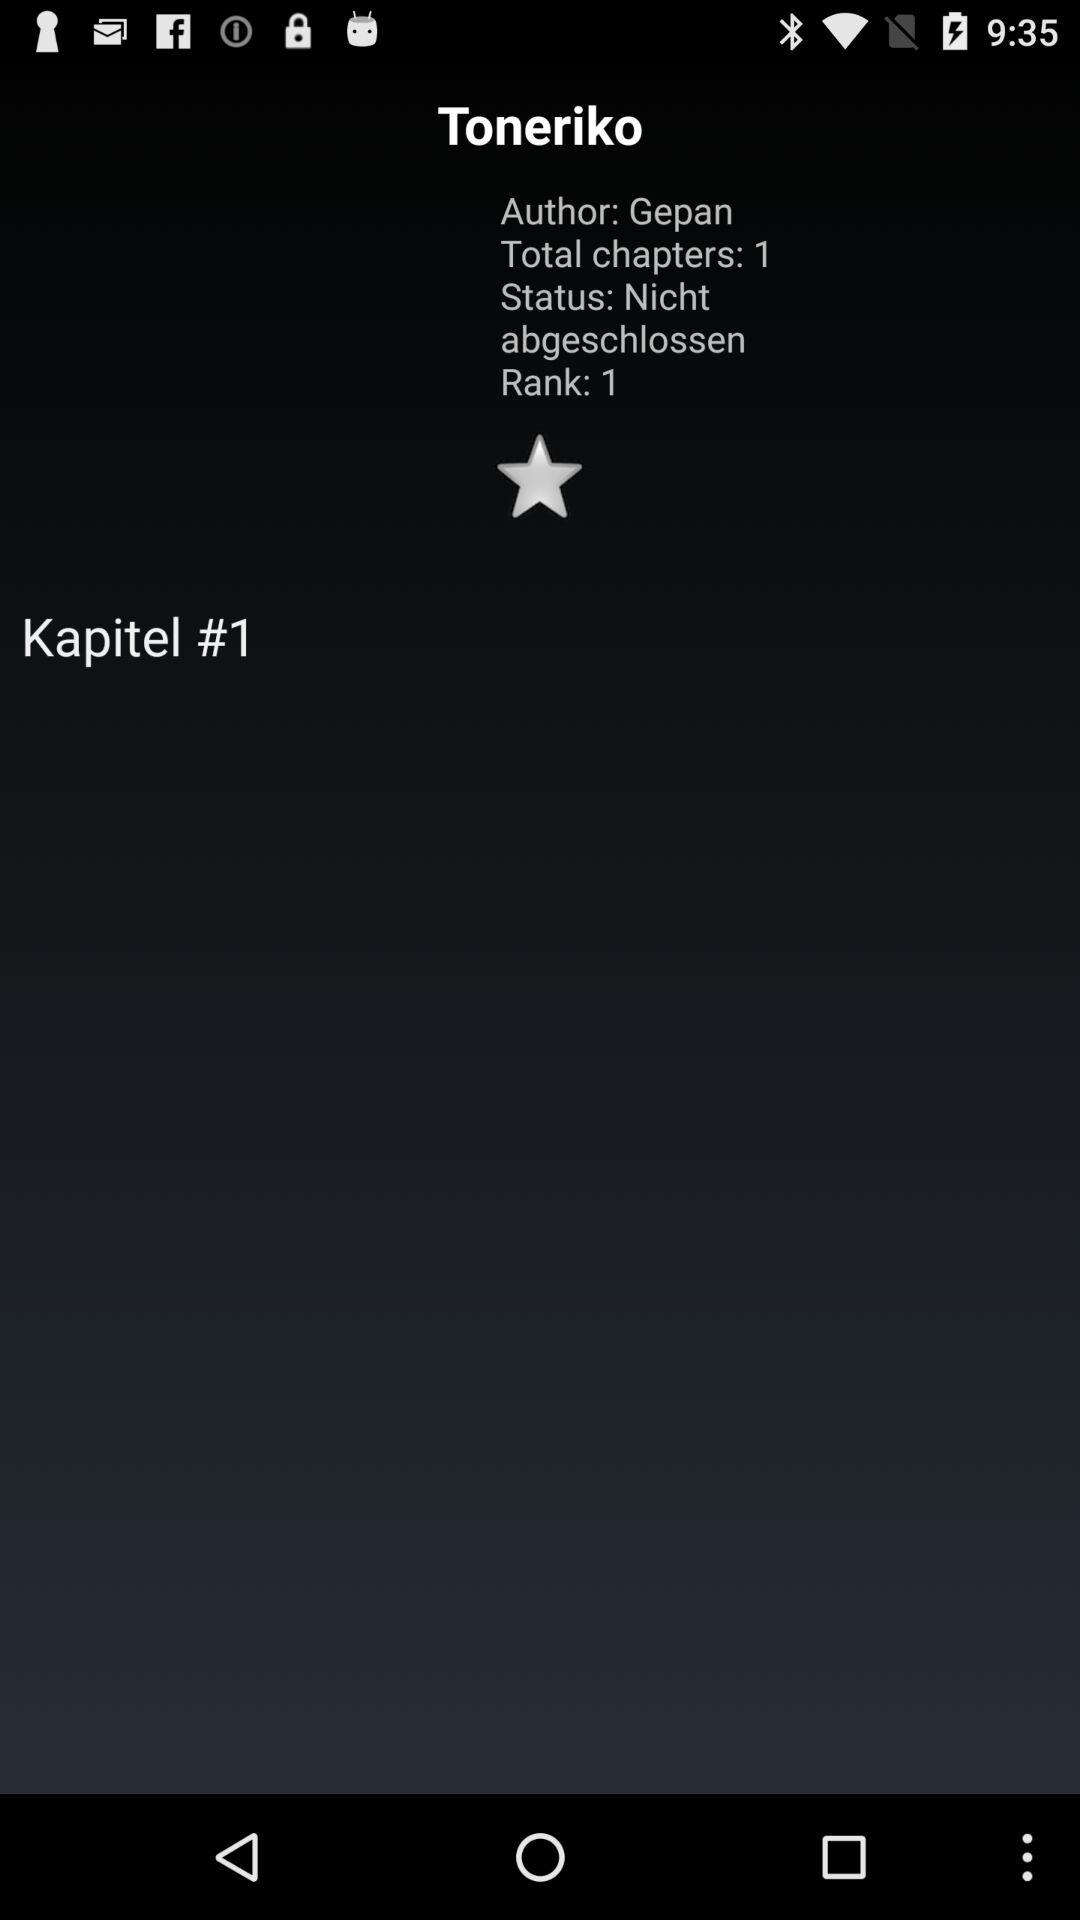How many chapters has this manga?
Answer the question using a single word or phrase. 1 